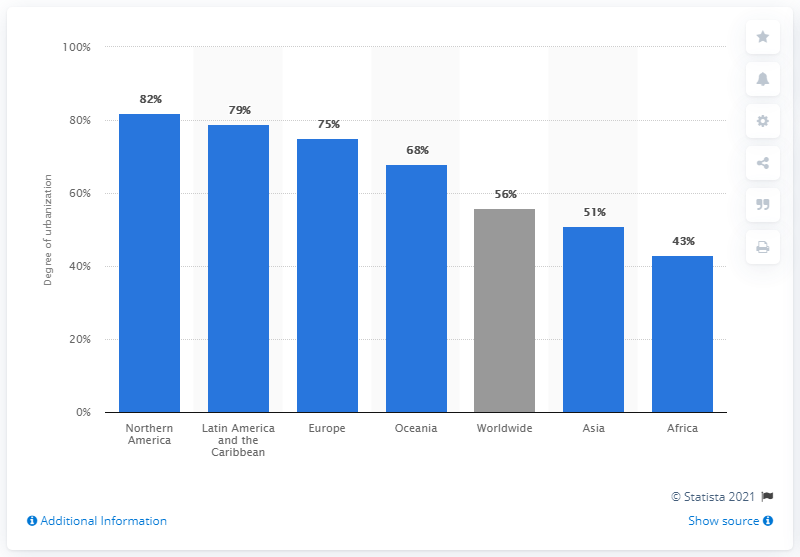Specify some key components in this picture. As of mid-2020, the worldwide percentage of urbanization was approximately 56%. 